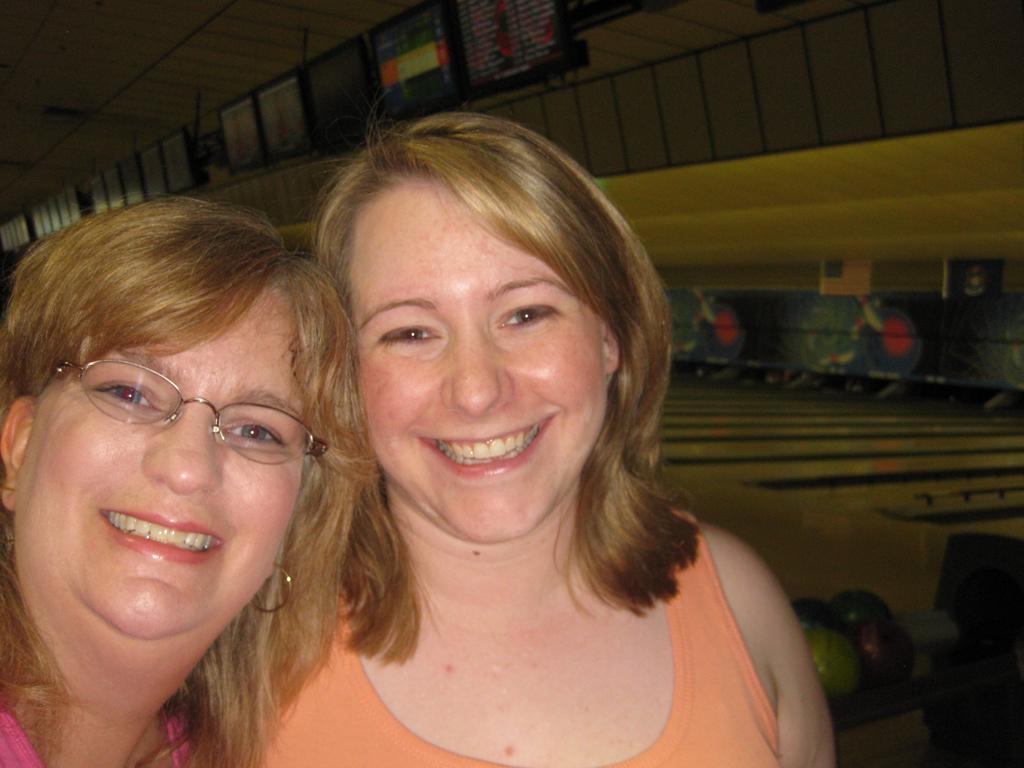Please provide a concise description of this image. In this image I can see two people with pink and orange color dresses. And these people are smiling. I can see one person with the specs. To the side I can see the bowling place and also I can see the balls which are in different colors. In the background there are screens. 